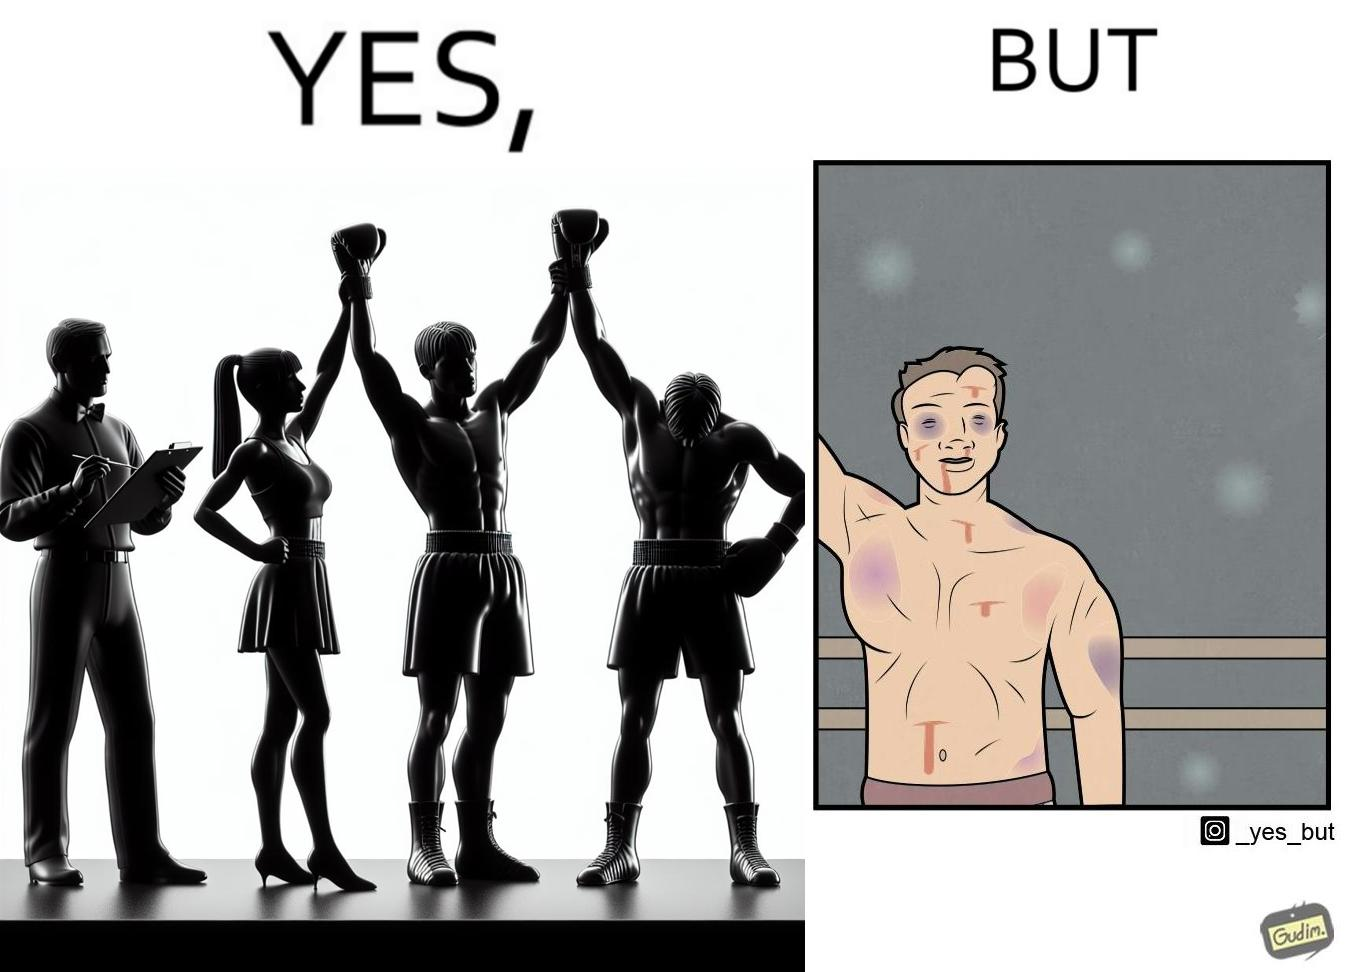What does this image depict? The image is ironic because even though a boxer has won the match and it is supposed to be a moment of celebration, the boxer got bruised in several places during the match. This is an illustration of what hurdles a person has to go through in order to succeed. 